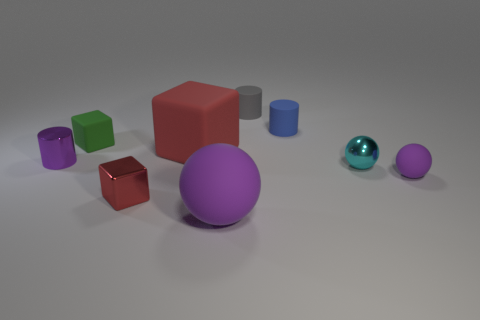How many large cyan cubes are made of the same material as the large ball?
Give a very brief answer. 0. What shape is the large object behind the small cyan shiny thing?
Your response must be concise. Cube. Do the tiny purple thing left of the green thing and the big red thing that is in front of the green matte cube have the same material?
Your response must be concise. No. Are there any big green objects that have the same shape as the cyan shiny thing?
Ensure brevity in your answer.  No. How many objects are either purple spheres behind the metal cube or gray things?
Make the answer very short. 2. Are there more purple matte balls that are to the right of the small blue cylinder than large rubber things in front of the tiny purple rubber object?
Your response must be concise. No. How many shiny things are brown cylinders or tiny green cubes?
Give a very brief answer. 0. What is the material of the thing that is the same color as the large matte block?
Give a very brief answer. Metal. Are there fewer red objects that are in front of the cyan sphere than purple spheres that are right of the gray matte thing?
Provide a succinct answer. No. What number of things are either tiny cyan things or spheres that are right of the gray object?
Offer a terse response. 2. 